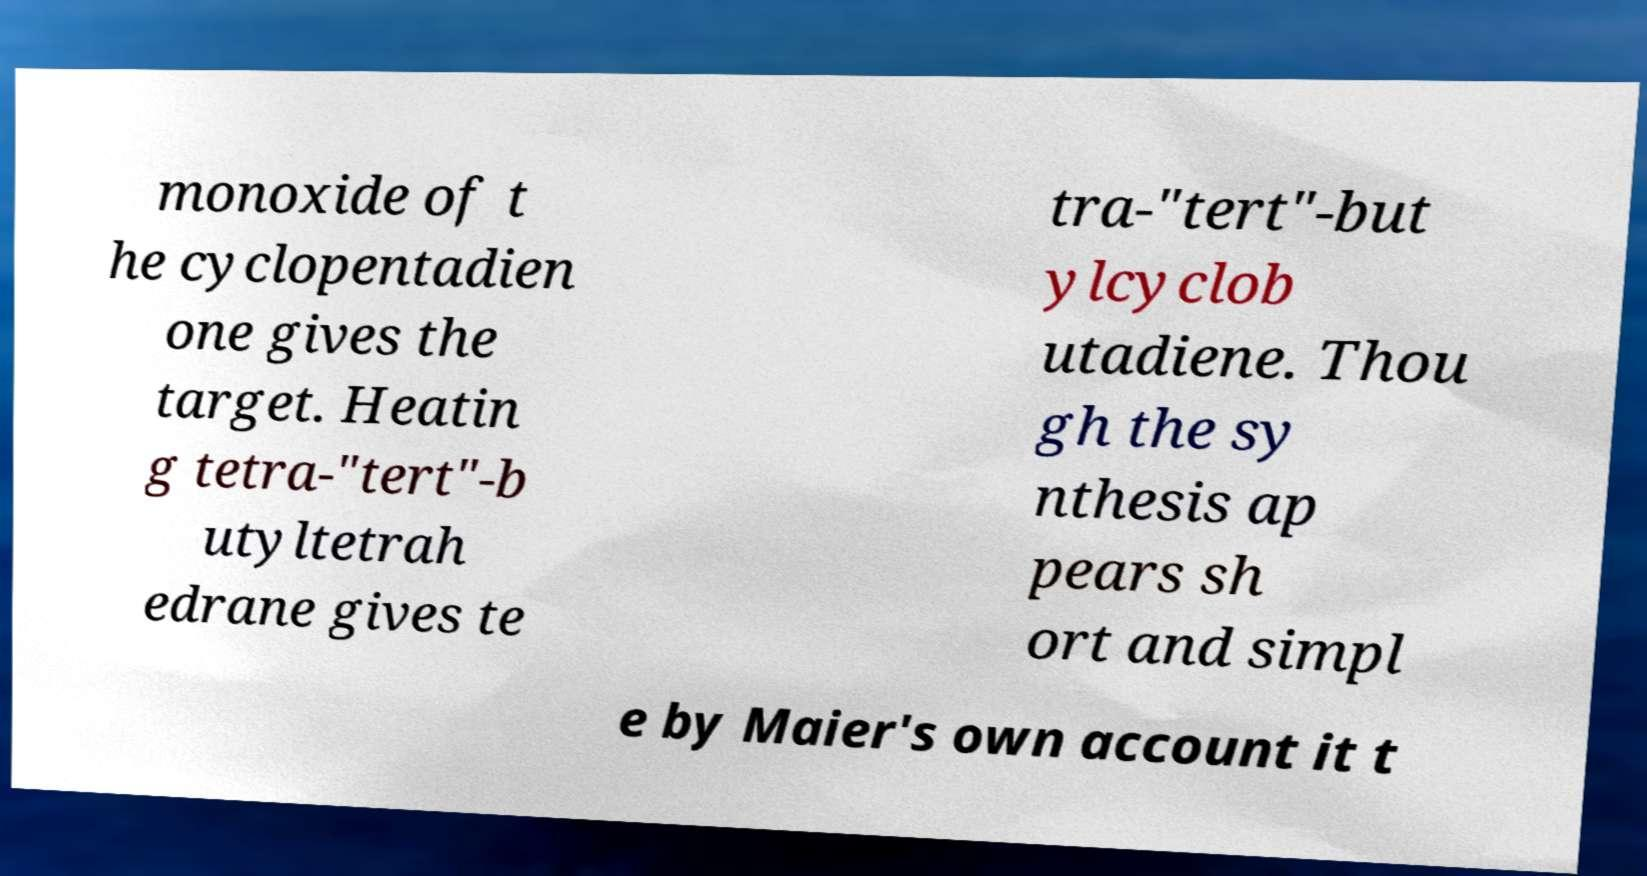Could you assist in decoding the text presented in this image and type it out clearly? monoxide of t he cyclopentadien one gives the target. Heatin g tetra-"tert"-b utyltetrah edrane gives te tra-"tert"-but ylcyclob utadiene. Thou gh the sy nthesis ap pears sh ort and simpl e by Maier's own account it t 